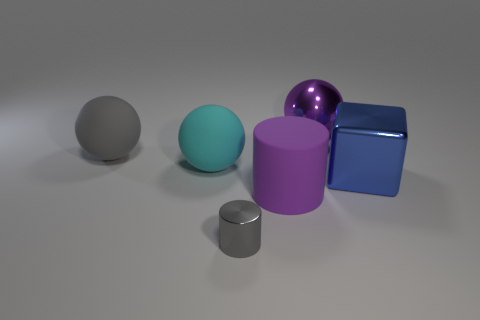Is there any other thing of the same color as the small thing?
Make the answer very short. Yes. What is the shape of the rubber object that is the same color as the large metal sphere?
Give a very brief answer. Cylinder. How many spheres are the same size as the blue block?
Offer a terse response. 3. Is the size of the cylinder that is right of the gray metallic object the same as the gray thing to the right of the big gray object?
Offer a very short reply. No. How many things are big rubber spheres or big purple things in front of the large block?
Ensure brevity in your answer.  3. The metallic cylinder has what color?
Offer a terse response. Gray. The big thing on the right side of the purple thing behind the rubber thing that is to the right of the tiny cylinder is made of what material?
Make the answer very short. Metal. What is the size of the sphere that is made of the same material as the big gray thing?
Offer a terse response. Large. Are there any big rubber cylinders that have the same color as the shiny ball?
Provide a short and direct response. Yes. There is a purple rubber thing; does it have the same size as the purple object behind the blue shiny block?
Offer a terse response. Yes. 